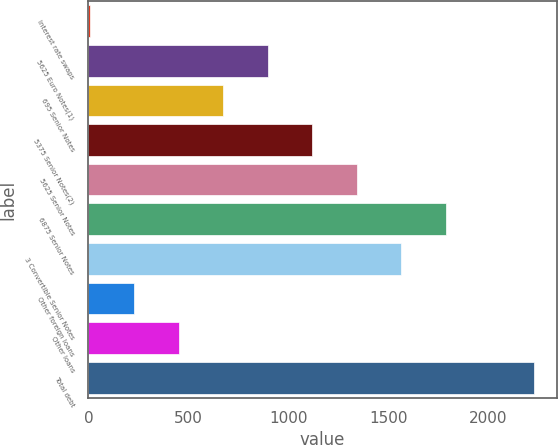Convert chart. <chart><loc_0><loc_0><loc_500><loc_500><bar_chart><fcel>Interest rate swaps<fcel>5625 Euro Notes(1)<fcel>695 Senior Notes<fcel>5375 Senior Notes(2)<fcel>5625 Senior Notes<fcel>6875 Senior Notes<fcel>3 Convertible Senior Notes<fcel>Other foreign loans<fcel>Other loans<fcel>Total debt<nl><fcel>7.6<fcel>897.2<fcel>674.8<fcel>1119.6<fcel>1342<fcel>1786.8<fcel>1564.4<fcel>230<fcel>452.4<fcel>2231.6<nl></chart> 